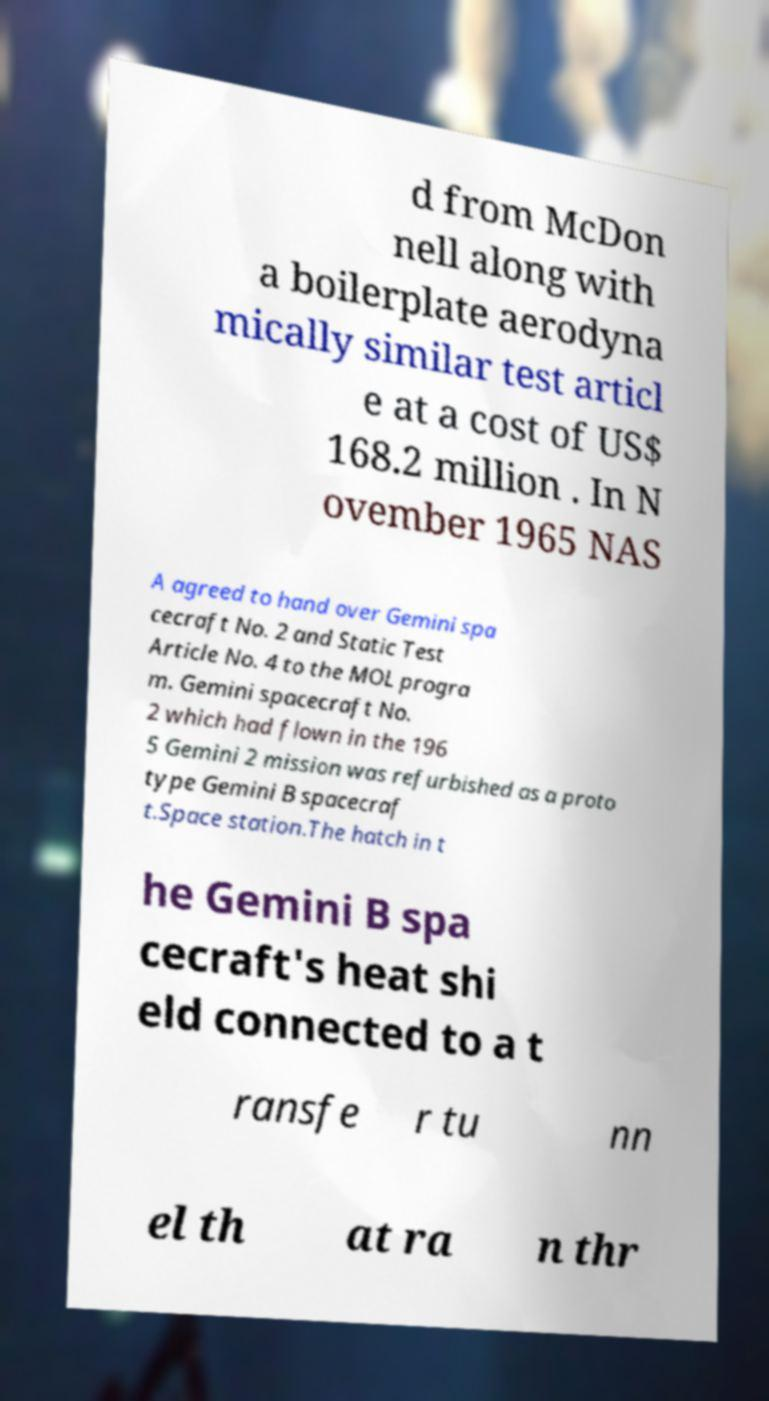Please identify and transcribe the text found in this image. d from McDon nell along with a boilerplate aerodyna mically similar test articl e at a cost of US$ 168.2 million . In N ovember 1965 NAS A agreed to hand over Gemini spa cecraft No. 2 and Static Test Article No. 4 to the MOL progra m. Gemini spacecraft No. 2 which had flown in the 196 5 Gemini 2 mission was refurbished as a proto type Gemini B spacecraf t.Space station.The hatch in t he Gemini B spa cecraft's heat shi eld connected to a t ransfe r tu nn el th at ra n thr 